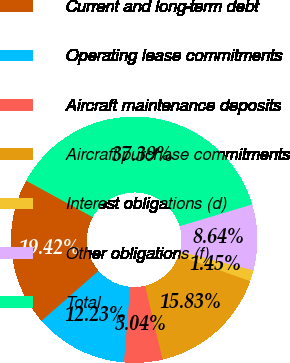Convert chart to OTSL. <chart><loc_0><loc_0><loc_500><loc_500><pie_chart><fcel>Current and long-term debt<fcel>Operating lease commitments<fcel>Aircraft maintenance deposits<fcel>Aircraft purchase commitments<fcel>Interest obligations (d)<fcel>Other obligations (f)<fcel>Total<nl><fcel>19.42%<fcel>12.23%<fcel>5.04%<fcel>15.83%<fcel>1.45%<fcel>8.64%<fcel>37.39%<nl></chart> 